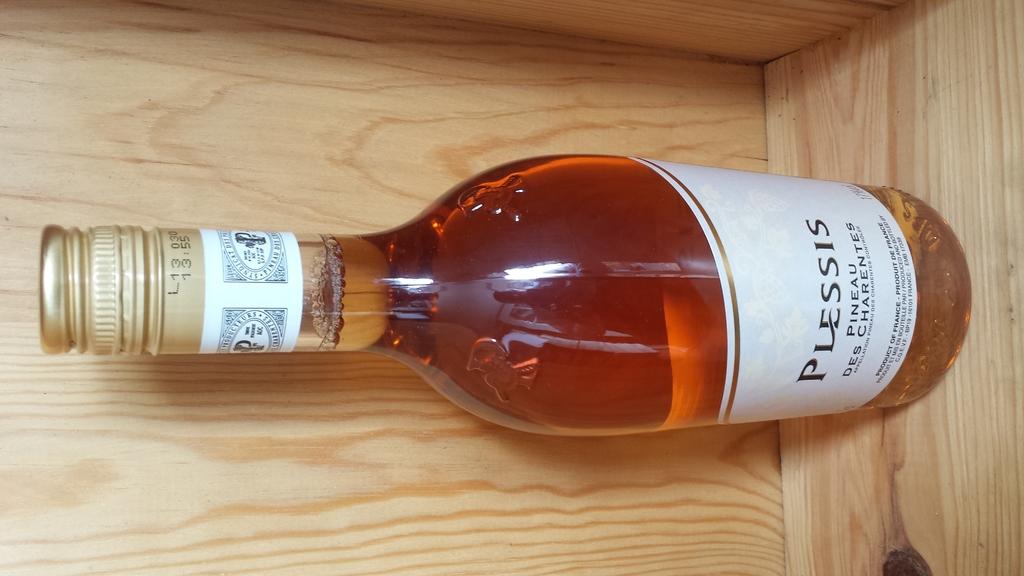What brand is this wine?
Your answer should be very brief. Plessis. 